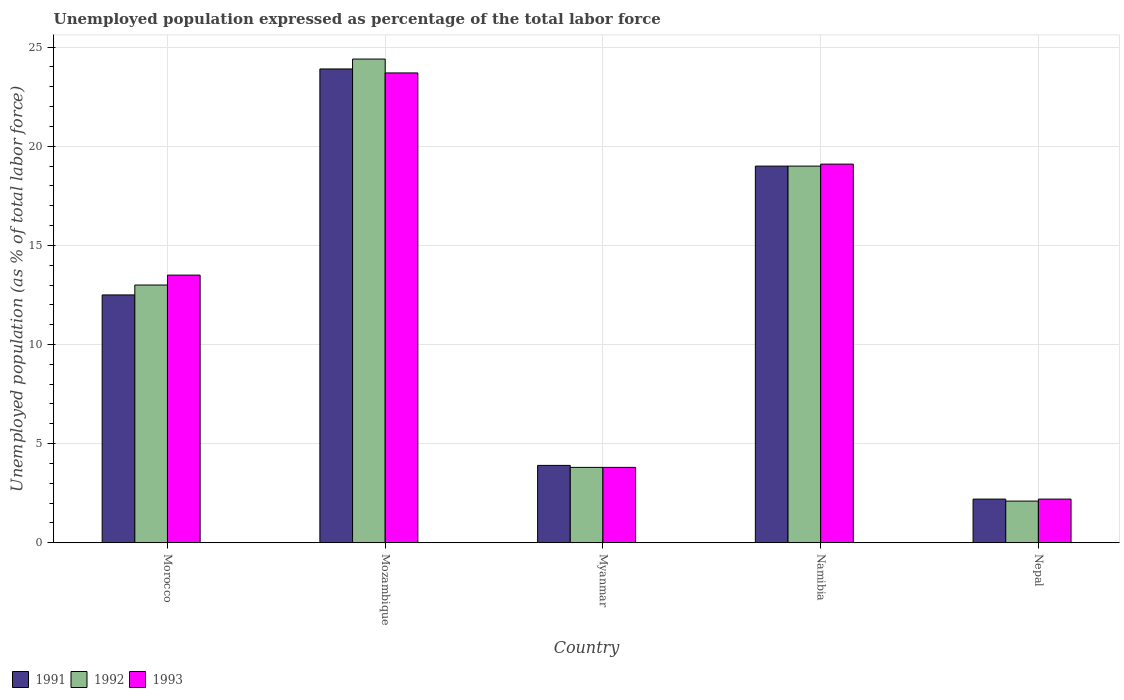How many different coloured bars are there?
Ensure brevity in your answer.  3. What is the label of the 4th group of bars from the left?
Make the answer very short. Namibia. In how many cases, is the number of bars for a given country not equal to the number of legend labels?
Your answer should be very brief. 0. What is the unemployment in in 1991 in Nepal?
Your answer should be very brief. 2.2. Across all countries, what is the maximum unemployment in in 1992?
Give a very brief answer. 24.4. Across all countries, what is the minimum unemployment in in 1991?
Ensure brevity in your answer.  2.2. In which country was the unemployment in in 1991 maximum?
Make the answer very short. Mozambique. In which country was the unemployment in in 1993 minimum?
Your response must be concise. Nepal. What is the total unemployment in in 1992 in the graph?
Provide a short and direct response. 62.3. What is the difference between the unemployment in in 1993 in Myanmar and the unemployment in in 1991 in Nepal?
Offer a very short reply. 1.6. What is the average unemployment in in 1991 per country?
Give a very brief answer. 12.3. What is the difference between the unemployment in of/in 1993 and unemployment in of/in 1992 in Namibia?
Make the answer very short. 0.1. In how many countries, is the unemployment in in 1993 greater than 7 %?
Offer a very short reply. 3. What is the ratio of the unemployment in in 1991 in Morocco to that in Nepal?
Your response must be concise. 5.68. Is the unemployment in in 1993 in Morocco less than that in Namibia?
Ensure brevity in your answer.  Yes. What is the difference between the highest and the second highest unemployment in in 1992?
Offer a very short reply. 5.4. What is the difference between the highest and the lowest unemployment in in 1993?
Your answer should be very brief. 21.5. Is the sum of the unemployment in in 1991 in Mozambique and Namibia greater than the maximum unemployment in in 1992 across all countries?
Your response must be concise. Yes. What does the 2nd bar from the right in Morocco represents?
Offer a very short reply. 1992. How many bars are there?
Your response must be concise. 15. How many countries are there in the graph?
Ensure brevity in your answer.  5. Does the graph contain any zero values?
Your response must be concise. No. Where does the legend appear in the graph?
Offer a very short reply. Bottom left. How are the legend labels stacked?
Your answer should be very brief. Horizontal. What is the title of the graph?
Provide a succinct answer. Unemployed population expressed as percentage of the total labor force. Does "1998" appear as one of the legend labels in the graph?
Make the answer very short. No. What is the label or title of the Y-axis?
Offer a very short reply. Unemployed population (as % of total labor force). What is the Unemployed population (as % of total labor force) in 1992 in Morocco?
Offer a terse response. 13. What is the Unemployed population (as % of total labor force) of 1991 in Mozambique?
Provide a short and direct response. 23.9. What is the Unemployed population (as % of total labor force) of 1992 in Mozambique?
Give a very brief answer. 24.4. What is the Unemployed population (as % of total labor force) of 1993 in Mozambique?
Offer a terse response. 23.7. What is the Unemployed population (as % of total labor force) in 1991 in Myanmar?
Your answer should be compact. 3.9. What is the Unemployed population (as % of total labor force) of 1992 in Myanmar?
Your answer should be very brief. 3.8. What is the Unemployed population (as % of total labor force) in 1993 in Myanmar?
Your response must be concise. 3.8. What is the Unemployed population (as % of total labor force) of 1991 in Namibia?
Give a very brief answer. 19. What is the Unemployed population (as % of total labor force) in 1992 in Namibia?
Your answer should be very brief. 19. What is the Unemployed population (as % of total labor force) in 1993 in Namibia?
Ensure brevity in your answer.  19.1. What is the Unemployed population (as % of total labor force) in 1991 in Nepal?
Keep it short and to the point. 2.2. What is the Unemployed population (as % of total labor force) in 1992 in Nepal?
Your response must be concise. 2.1. What is the Unemployed population (as % of total labor force) of 1993 in Nepal?
Provide a succinct answer. 2.2. Across all countries, what is the maximum Unemployed population (as % of total labor force) of 1991?
Keep it short and to the point. 23.9. Across all countries, what is the maximum Unemployed population (as % of total labor force) of 1992?
Give a very brief answer. 24.4. Across all countries, what is the maximum Unemployed population (as % of total labor force) in 1993?
Ensure brevity in your answer.  23.7. Across all countries, what is the minimum Unemployed population (as % of total labor force) of 1991?
Your answer should be compact. 2.2. Across all countries, what is the minimum Unemployed population (as % of total labor force) in 1992?
Make the answer very short. 2.1. Across all countries, what is the minimum Unemployed population (as % of total labor force) of 1993?
Your answer should be very brief. 2.2. What is the total Unemployed population (as % of total labor force) in 1991 in the graph?
Keep it short and to the point. 61.5. What is the total Unemployed population (as % of total labor force) in 1992 in the graph?
Your answer should be very brief. 62.3. What is the total Unemployed population (as % of total labor force) of 1993 in the graph?
Your answer should be very brief. 62.3. What is the difference between the Unemployed population (as % of total labor force) of 1992 in Morocco and that in Mozambique?
Give a very brief answer. -11.4. What is the difference between the Unemployed population (as % of total labor force) of 1993 in Morocco and that in Mozambique?
Offer a very short reply. -10.2. What is the difference between the Unemployed population (as % of total labor force) of 1993 in Morocco and that in Myanmar?
Your answer should be compact. 9.7. What is the difference between the Unemployed population (as % of total labor force) in 1992 in Morocco and that in Namibia?
Offer a terse response. -6. What is the difference between the Unemployed population (as % of total labor force) of 1993 in Morocco and that in Namibia?
Your answer should be very brief. -5.6. What is the difference between the Unemployed population (as % of total labor force) of 1993 in Morocco and that in Nepal?
Keep it short and to the point. 11.3. What is the difference between the Unemployed population (as % of total labor force) of 1991 in Mozambique and that in Myanmar?
Your answer should be compact. 20. What is the difference between the Unemployed population (as % of total labor force) of 1992 in Mozambique and that in Myanmar?
Your answer should be very brief. 20.6. What is the difference between the Unemployed population (as % of total labor force) in 1993 in Mozambique and that in Myanmar?
Give a very brief answer. 19.9. What is the difference between the Unemployed population (as % of total labor force) in 1991 in Mozambique and that in Nepal?
Your answer should be compact. 21.7. What is the difference between the Unemployed population (as % of total labor force) in 1992 in Mozambique and that in Nepal?
Ensure brevity in your answer.  22.3. What is the difference between the Unemployed population (as % of total labor force) of 1993 in Mozambique and that in Nepal?
Keep it short and to the point. 21.5. What is the difference between the Unemployed population (as % of total labor force) of 1991 in Myanmar and that in Namibia?
Make the answer very short. -15.1. What is the difference between the Unemployed population (as % of total labor force) of 1992 in Myanmar and that in Namibia?
Offer a terse response. -15.2. What is the difference between the Unemployed population (as % of total labor force) in 1993 in Myanmar and that in Namibia?
Keep it short and to the point. -15.3. What is the difference between the Unemployed population (as % of total labor force) in 1991 in Myanmar and that in Nepal?
Offer a terse response. 1.7. What is the difference between the Unemployed population (as % of total labor force) of 1992 in Myanmar and that in Nepal?
Your response must be concise. 1.7. What is the difference between the Unemployed population (as % of total labor force) of 1991 in Namibia and that in Nepal?
Your answer should be very brief. 16.8. What is the difference between the Unemployed population (as % of total labor force) in 1992 in Namibia and that in Nepal?
Offer a terse response. 16.9. What is the difference between the Unemployed population (as % of total labor force) in 1993 in Namibia and that in Nepal?
Your answer should be compact. 16.9. What is the difference between the Unemployed population (as % of total labor force) of 1991 in Morocco and the Unemployed population (as % of total labor force) of 1992 in Mozambique?
Your response must be concise. -11.9. What is the difference between the Unemployed population (as % of total labor force) of 1991 in Morocco and the Unemployed population (as % of total labor force) of 1992 in Myanmar?
Give a very brief answer. 8.7. What is the difference between the Unemployed population (as % of total labor force) in 1992 in Morocco and the Unemployed population (as % of total labor force) in 1993 in Myanmar?
Keep it short and to the point. 9.2. What is the difference between the Unemployed population (as % of total labor force) of 1991 in Morocco and the Unemployed population (as % of total labor force) of 1992 in Nepal?
Your answer should be compact. 10.4. What is the difference between the Unemployed population (as % of total labor force) of 1991 in Mozambique and the Unemployed population (as % of total labor force) of 1992 in Myanmar?
Your response must be concise. 20.1. What is the difference between the Unemployed population (as % of total labor force) of 1991 in Mozambique and the Unemployed population (as % of total labor force) of 1993 in Myanmar?
Offer a very short reply. 20.1. What is the difference between the Unemployed population (as % of total labor force) of 1992 in Mozambique and the Unemployed population (as % of total labor force) of 1993 in Myanmar?
Keep it short and to the point. 20.6. What is the difference between the Unemployed population (as % of total labor force) of 1991 in Mozambique and the Unemployed population (as % of total labor force) of 1992 in Namibia?
Make the answer very short. 4.9. What is the difference between the Unemployed population (as % of total labor force) of 1992 in Mozambique and the Unemployed population (as % of total labor force) of 1993 in Namibia?
Make the answer very short. 5.3. What is the difference between the Unemployed population (as % of total labor force) of 1991 in Mozambique and the Unemployed population (as % of total labor force) of 1992 in Nepal?
Provide a succinct answer. 21.8. What is the difference between the Unemployed population (as % of total labor force) in 1991 in Mozambique and the Unemployed population (as % of total labor force) in 1993 in Nepal?
Offer a very short reply. 21.7. What is the difference between the Unemployed population (as % of total labor force) in 1992 in Mozambique and the Unemployed population (as % of total labor force) in 1993 in Nepal?
Provide a succinct answer. 22.2. What is the difference between the Unemployed population (as % of total labor force) in 1991 in Myanmar and the Unemployed population (as % of total labor force) in 1992 in Namibia?
Your response must be concise. -15.1. What is the difference between the Unemployed population (as % of total labor force) of 1991 in Myanmar and the Unemployed population (as % of total labor force) of 1993 in Namibia?
Your answer should be very brief. -15.2. What is the difference between the Unemployed population (as % of total labor force) in 1992 in Myanmar and the Unemployed population (as % of total labor force) in 1993 in Namibia?
Give a very brief answer. -15.3. What is the difference between the Unemployed population (as % of total labor force) in 1991 in Myanmar and the Unemployed population (as % of total labor force) in 1992 in Nepal?
Offer a very short reply. 1.8. What is the difference between the Unemployed population (as % of total labor force) in 1991 in Namibia and the Unemployed population (as % of total labor force) in 1992 in Nepal?
Make the answer very short. 16.9. What is the difference between the Unemployed population (as % of total labor force) of 1991 in Namibia and the Unemployed population (as % of total labor force) of 1993 in Nepal?
Your response must be concise. 16.8. What is the average Unemployed population (as % of total labor force) of 1992 per country?
Provide a succinct answer. 12.46. What is the average Unemployed population (as % of total labor force) in 1993 per country?
Offer a terse response. 12.46. What is the difference between the Unemployed population (as % of total labor force) of 1992 and Unemployed population (as % of total labor force) of 1993 in Morocco?
Ensure brevity in your answer.  -0.5. What is the difference between the Unemployed population (as % of total labor force) of 1991 and Unemployed population (as % of total labor force) of 1992 in Myanmar?
Your answer should be very brief. 0.1. What is the difference between the Unemployed population (as % of total labor force) in 1991 and Unemployed population (as % of total labor force) in 1993 in Namibia?
Offer a terse response. -0.1. What is the difference between the Unemployed population (as % of total labor force) of 1991 and Unemployed population (as % of total labor force) of 1992 in Nepal?
Provide a short and direct response. 0.1. What is the difference between the Unemployed population (as % of total labor force) of 1991 and Unemployed population (as % of total labor force) of 1993 in Nepal?
Offer a very short reply. 0. What is the difference between the Unemployed population (as % of total labor force) in 1992 and Unemployed population (as % of total labor force) in 1993 in Nepal?
Give a very brief answer. -0.1. What is the ratio of the Unemployed population (as % of total labor force) of 1991 in Morocco to that in Mozambique?
Keep it short and to the point. 0.52. What is the ratio of the Unemployed population (as % of total labor force) of 1992 in Morocco to that in Mozambique?
Make the answer very short. 0.53. What is the ratio of the Unemployed population (as % of total labor force) of 1993 in Morocco to that in Mozambique?
Provide a succinct answer. 0.57. What is the ratio of the Unemployed population (as % of total labor force) of 1991 in Morocco to that in Myanmar?
Ensure brevity in your answer.  3.21. What is the ratio of the Unemployed population (as % of total labor force) of 1992 in Morocco to that in Myanmar?
Your answer should be compact. 3.42. What is the ratio of the Unemployed population (as % of total labor force) of 1993 in Morocco to that in Myanmar?
Your answer should be very brief. 3.55. What is the ratio of the Unemployed population (as % of total labor force) in 1991 in Morocco to that in Namibia?
Keep it short and to the point. 0.66. What is the ratio of the Unemployed population (as % of total labor force) in 1992 in Morocco to that in Namibia?
Offer a terse response. 0.68. What is the ratio of the Unemployed population (as % of total labor force) of 1993 in Morocco to that in Namibia?
Your answer should be very brief. 0.71. What is the ratio of the Unemployed population (as % of total labor force) of 1991 in Morocco to that in Nepal?
Provide a short and direct response. 5.68. What is the ratio of the Unemployed population (as % of total labor force) of 1992 in Morocco to that in Nepal?
Your response must be concise. 6.19. What is the ratio of the Unemployed population (as % of total labor force) in 1993 in Morocco to that in Nepal?
Give a very brief answer. 6.14. What is the ratio of the Unemployed population (as % of total labor force) of 1991 in Mozambique to that in Myanmar?
Provide a short and direct response. 6.13. What is the ratio of the Unemployed population (as % of total labor force) in 1992 in Mozambique to that in Myanmar?
Offer a very short reply. 6.42. What is the ratio of the Unemployed population (as % of total labor force) of 1993 in Mozambique to that in Myanmar?
Your answer should be very brief. 6.24. What is the ratio of the Unemployed population (as % of total labor force) in 1991 in Mozambique to that in Namibia?
Keep it short and to the point. 1.26. What is the ratio of the Unemployed population (as % of total labor force) of 1992 in Mozambique to that in Namibia?
Your response must be concise. 1.28. What is the ratio of the Unemployed population (as % of total labor force) in 1993 in Mozambique to that in Namibia?
Keep it short and to the point. 1.24. What is the ratio of the Unemployed population (as % of total labor force) of 1991 in Mozambique to that in Nepal?
Your response must be concise. 10.86. What is the ratio of the Unemployed population (as % of total labor force) of 1992 in Mozambique to that in Nepal?
Make the answer very short. 11.62. What is the ratio of the Unemployed population (as % of total labor force) in 1993 in Mozambique to that in Nepal?
Make the answer very short. 10.77. What is the ratio of the Unemployed population (as % of total labor force) of 1991 in Myanmar to that in Namibia?
Give a very brief answer. 0.21. What is the ratio of the Unemployed population (as % of total labor force) in 1993 in Myanmar to that in Namibia?
Keep it short and to the point. 0.2. What is the ratio of the Unemployed population (as % of total labor force) of 1991 in Myanmar to that in Nepal?
Give a very brief answer. 1.77. What is the ratio of the Unemployed population (as % of total labor force) of 1992 in Myanmar to that in Nepal?
Keep it short and to the point. 1.81. What is the ratio of the Unemployed population (as % of total labor force) in 1993 in Myanmar to that in Nepal?
Your response must be concise. 1.73. What is the ratio of the Unemployed population (as % of total labor force) of 1991 in Namibia to that in Nepal?
Provide a succinct answer. 8.64. What is the ratio of the Unemployed population (as % of total labor force) of 1992 in Namibia to that in Nepal?
Your answer should be very brief. 9.05. What is the ratio of the Unemployed population (as % of total labor force) of 1993 in Namibia to that in Nepal?
Give a very brief answer. 8.68. What is the difference between the highest and the second highest Unemployed population (as % of total labor force) in 1992?
Offer a very short reply. 5.4. What is the difference between the highest and the second highest Unemployed population (as % of total labor force) in 1993?
Provide a succinct answer. 4.6. What is the difference between the highest and the lowest Unemployed population (as % of total labor force) in 1991?
Offer a terse response. 21.7. What is the difference between the highest and the lowest Unemployed population (as % of total labor force) of 1992?
Keep it short and to the point. 22.3. 